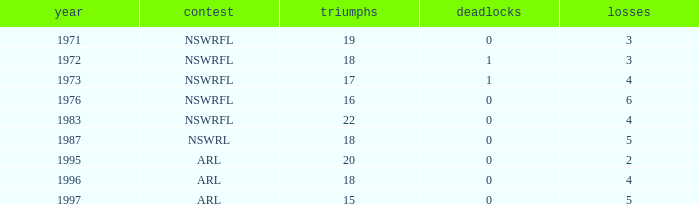What average Year has Losses 4, and Wins less than 18, and Draws greater than 1? None. 